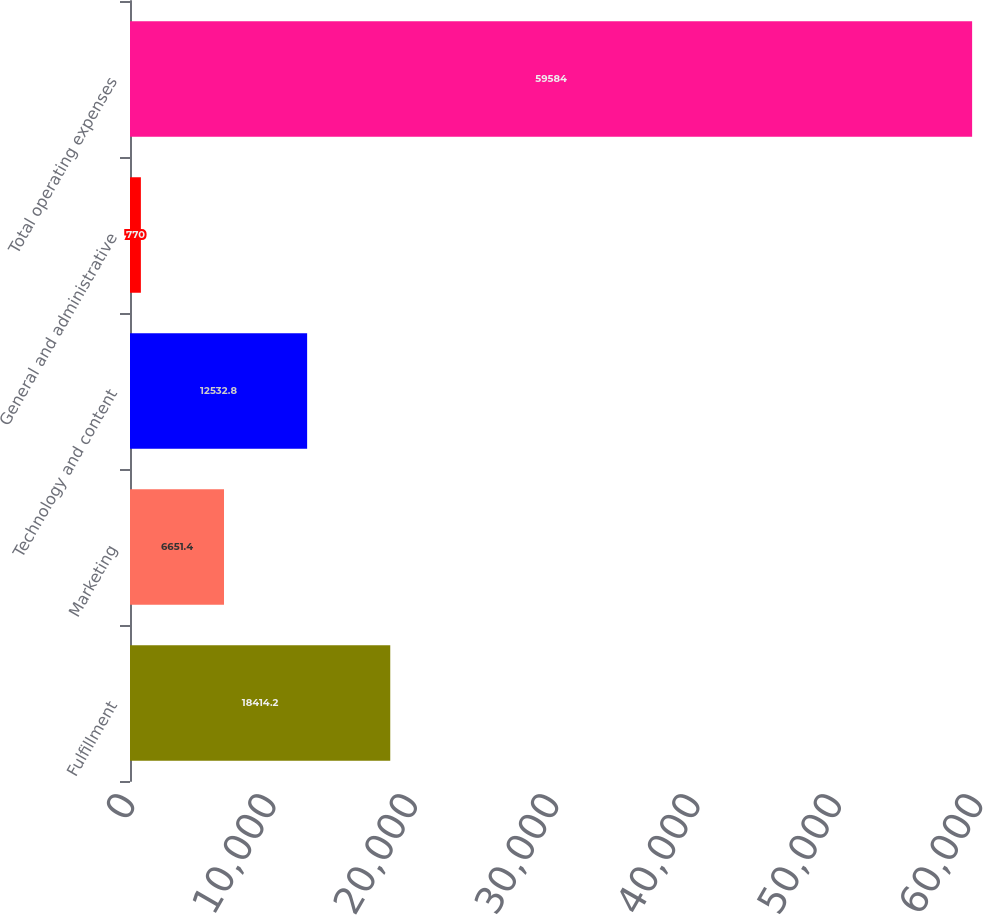<chart> <loc_0><loc_0><loc_500><loc_500><bar_chart><fcel>Fulfillment<fcel>Marketing<fcel>Technology and content<fcel>General and administrative<fcel>Total operating expenses<nl><fcel>18414.2<fcel>6651.4<fcel>12532.8<fcel>770<fcel>59584<nl></chart> 